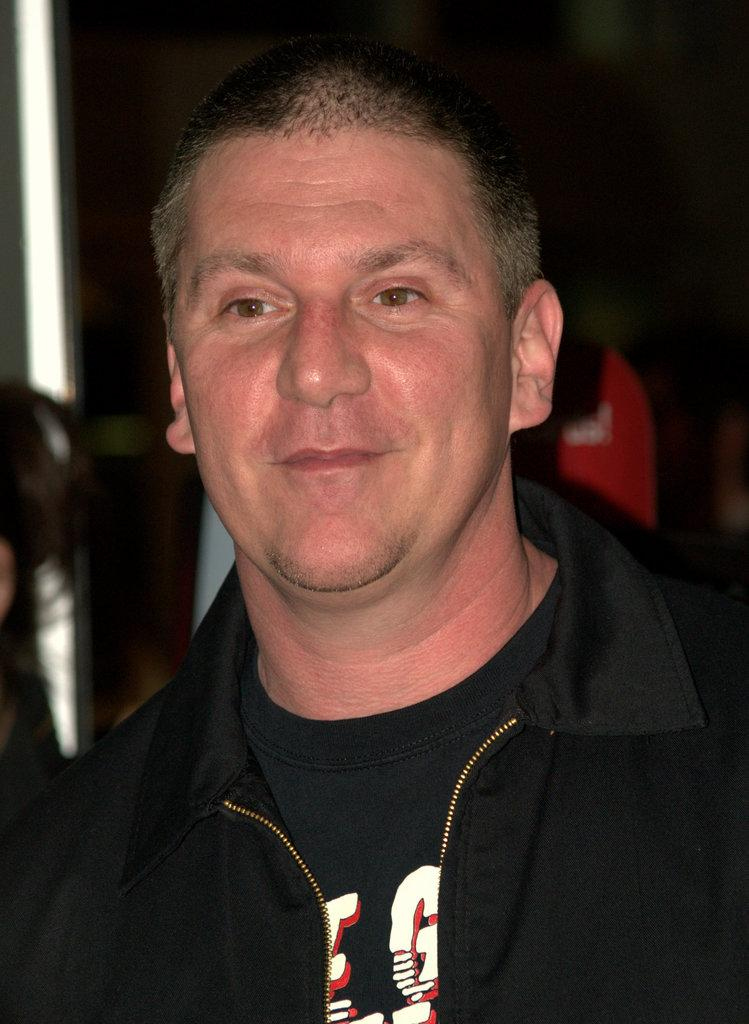What is the main subject of the image? There is a person in the image. What is the person wearing on their upper body? The person is wearing a black shirt and a black jacket. Can you describe the background of the image? The background of the image is blurry. What type of voyage is the person embarking on in the image? There is no indication of a voyage in the image; it only shows a person wearing a black shirt and a black jacket with a blurry background. 